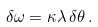<formula> <loc_0><loc_0><loc_500><loc_500>\delta \omega = \kappa \lambda \, \delta \theta \, .</formula> 